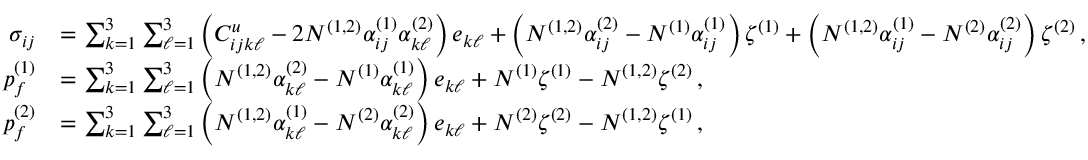<formula> <loc_0><loc_0><loc_500><loc_500>\begin{array} { r l } { \sigma _ { i j } } & { = \sum _ { k = 1 } ^ { 3 } \sum _ { \ell = 1 } ^ { 3 } \left ( C _ { i j k \ell } ^ { u } - 2 N ^ { ( 1 , 2 ) } \alpha _ { i j } ^ { ( 1 ) } \alpha _ { k \ell } ^ { ( 2 ) } \right ) e _ { k \ell } + \left ( N ^ { ( 1 , 2 ) } \alpha _ { i j } ^ { ( 2 ) } - N ^ { ( 1 ) } \alpha _ { i j } ^ { ( 1 ) } \right ) \zeta ^ { ( 1 ) } + \left ( N ^ { ( 1 , 2 ) } \alpha _ { i j } ^ { ( 1 ) } - N ^ { ( 2 ) } \alpha _ { i j } ^ { ( 2 ) } \right ) \zeta ^ { ( 2 ) } \, , } \\ { p _ { f } ^ { ( 1 ) } } & { = \sum _ { k = 1 } ^ { 3 } \sum _ { \ell = 1 } ^ { 3 } \left ( N ^ { ( 1 , 2 ) } \alpha _ { k \ell } ^ { ( 2 ) } - N ^ { ( 1 ) } \alpha _ { k \ell } ^ { ( 1 ) } \right ) e _ { k \ell } + N ^ { ( 1 ) } \zeta ^ { ( 1 ) } - N ^ { ( 1 , 2 ) } \zeta ^ { ( 2 ) } \, , } \\ { p _ { f } ^ { ( 2 ) } } & { = \sum _ { k = 1 } ^ { 3 } \sum _ { \ell = 1 } ^ { 3 } \left ( N ^ { ( 1 , 2 ) } \alpha _ { k \ell } ^ { ( 1 ) } - N ^ { ( 2 ) } \alpha _ { k \ell } ^ { ( 2 ) } \right ) e _ { k \ell } + N ^ { ( 2 ) } \zeta ^ { ( 2 ) } - N ^ { ( 1 , 2 ) } \zeta ^ { ( 1 ) } \, , } \end{array}</formula> 